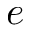<formula> <loc_0><loc_0><loc_500><loc_500>e</formula> 